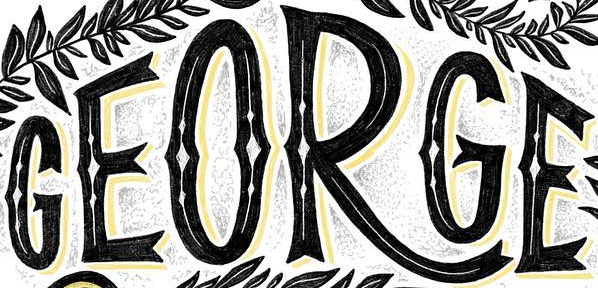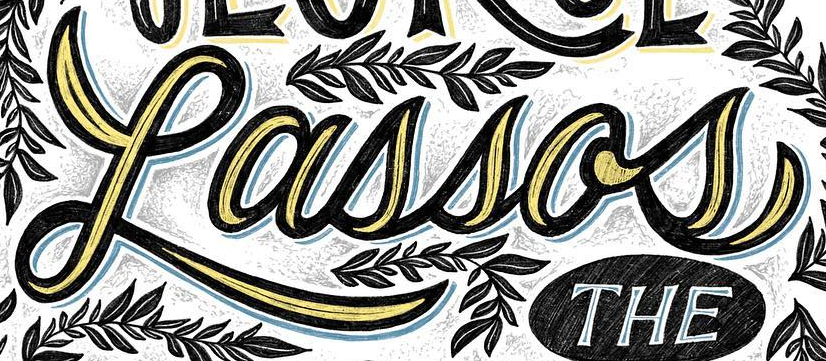What text appears in these images from left to right, separated by a semicolon? GEORGE; Lassos 